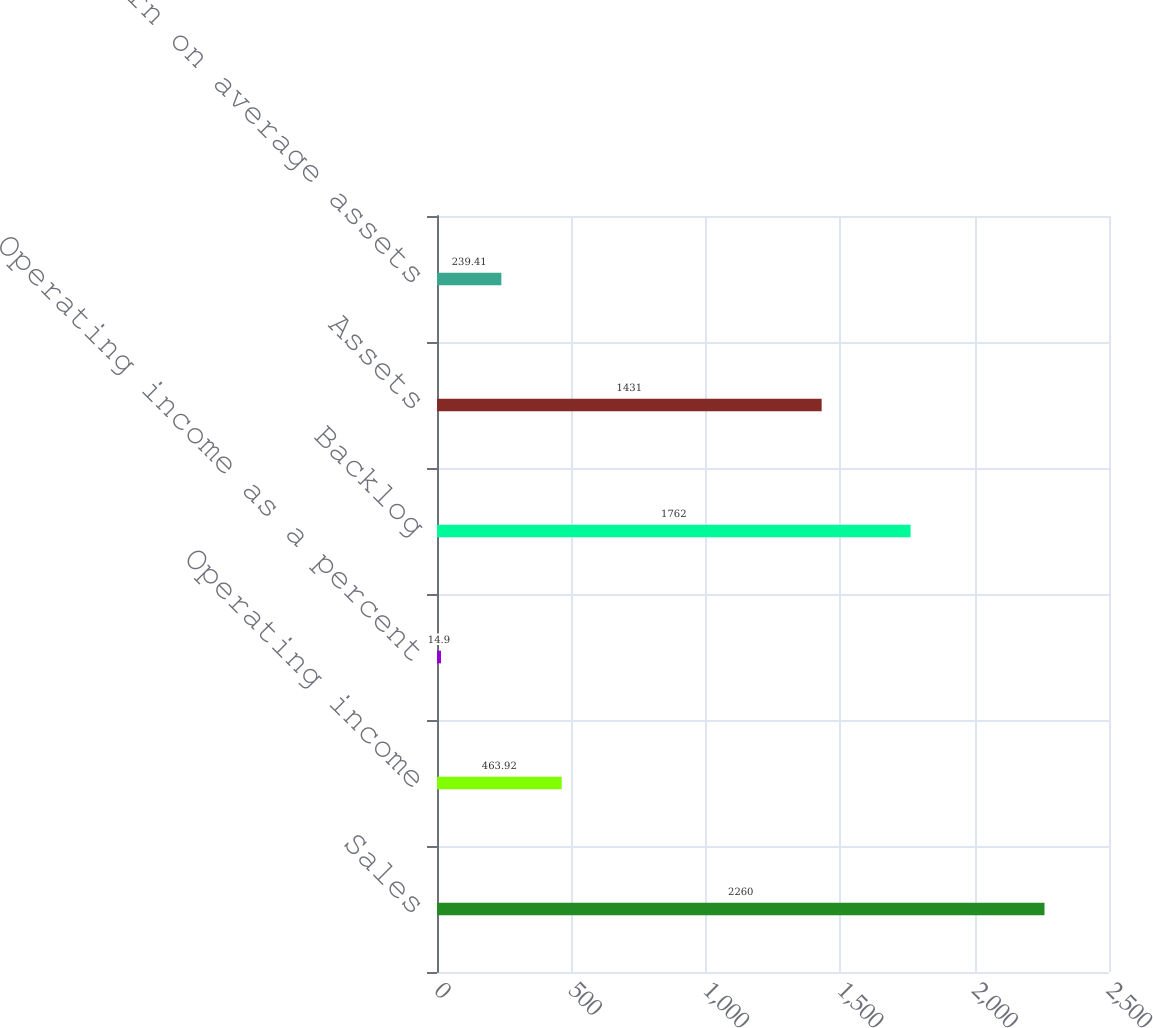<chart> <loc_0><loc_0><loc_500><loc_500><bar_chart><fcel>Sales<fcel>Operating income<fcel>Operating income as a percent<fcel>Backlog<fcel>Assets<fcel>Return on average assets<nl><fcel>2260<fcel>463.92<fcel>14.9<fcel>1762<fcel>1431<fcel>239.41<nl></chart> 